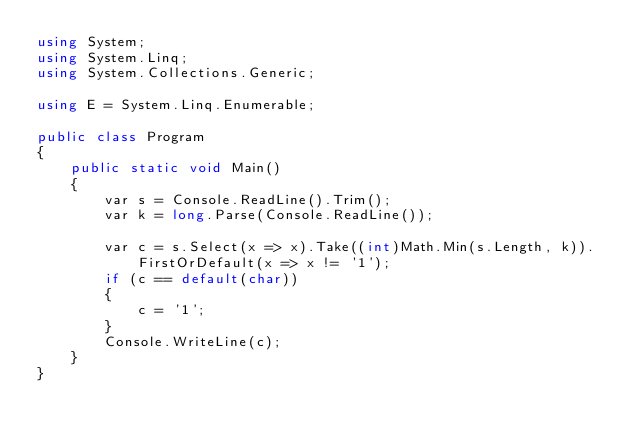Convert code to text. <code><loc_0><loc_0><loc_500><loc_500><_C#_>using System;
using System.Linq;
using System.Collections.Generic;

using E = System.Linq.Enumerable;

public class Program
{
    public static void Main()
    {
        var s = Console.ReadLine().Trim();
        var k = long.Parse(Console.ReadLine());

        var c = s.Select(x => x).Take((int)Math.Min(s.Length, k)).FirstOrDefault(x => x != '1');
        if (c == default(char))
        {
            c = '1';
        }
        Console.WriteLine(c);
    }
}</code> 